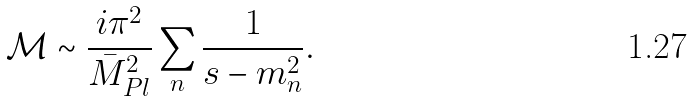Convert formula to latex. <formula><loc_0><loc_0><loc_500><loc_500>\mathcal { M } \sim \frac { i \pi ^ { 2 } } { { \bar { M } } _ { P l } ^ { 2 } } \sum _ { n } \frac { 1 } { s - m _ { n } ^ { 2 } } .</formula> 